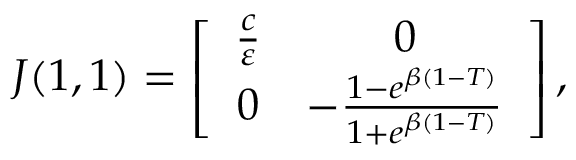Convert formula to latex. <formula><loc_0><loc_0><loc_500><loc_500>\begin{array} { r } { J ( 1 , 1 ) = \left [ { \begin{array} { c c } { \frac { c } { \varepsilon } } & { 0 } \\ { 0 } & { - \frac { 1 - e ^ { \beta ( 1 - T ) } } { 1 + e ^ { \beta ( 1 - T ) } } } \end{array} } \right ] , } \end{array}</formula> 